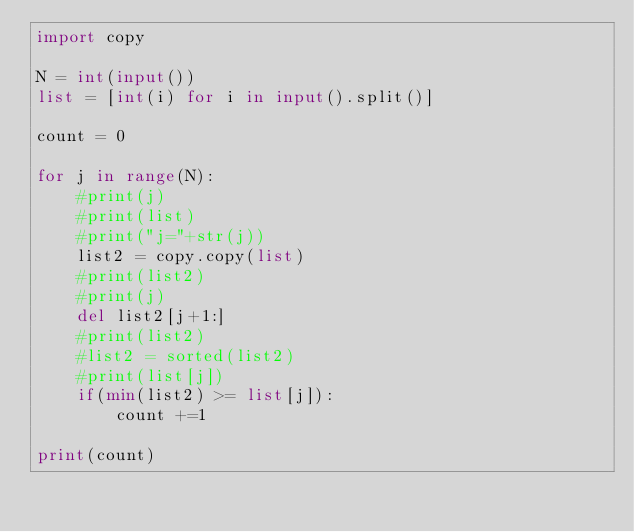Convert code to text. <code><loc_0><loc_0><loc_500><loc_500><_Python_>import copy

N = int(input())
list = [int(i) for i in input().split()]

count = 0

for j in range(N):
    #print(j)
    #print(list)
    #print("j="+str(j))
    list2 = copy.copy(list)
    #print(list2)
    #print(j)
    del list2[j+1:]
    #print(list2)
    #list2 = sorted(list2)
    #print(list[j])
    if(min(list2) >= list[j]):
        count +=1

print(count)
</code> 